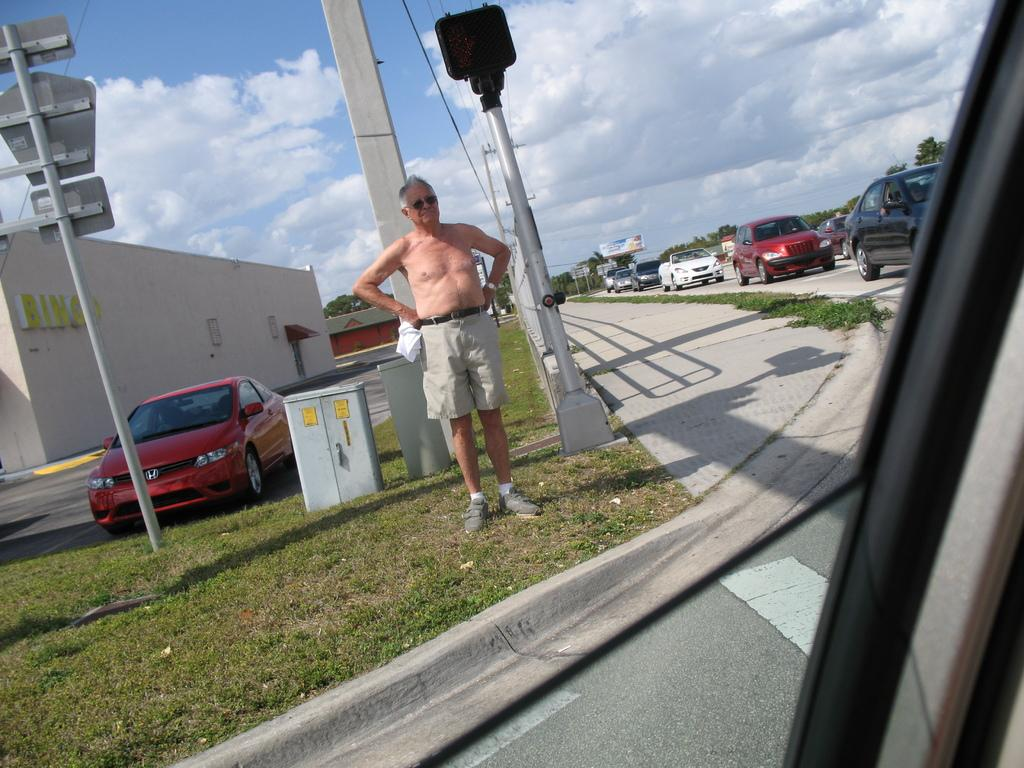What type of structure is visible in the image? There is a house in the image. What type of vegetation is present in the image? There is grass in the image. What type of vehicles can be seen in the image? There are cars in the image. Can you describe the person in the image? There is a person standing in the image. What can be seen in the background of the image? There are trees in the background of the image. What is visible at the top of the image? The sky is visible at the top of the image. What can be observed in the sky? Clouds are present in the sky. What type of judge is sitting in the room in the image? There is no judge or room present in the image. What type of gun is visible in the image? There is no gun present in the image. 